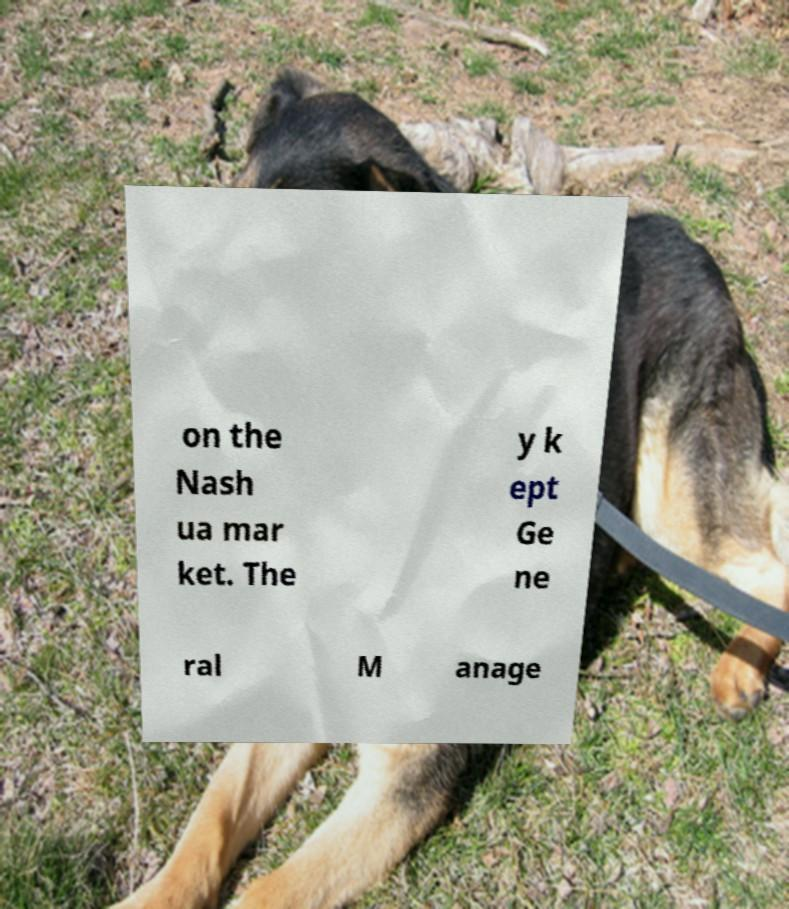There's text embedded in this image that I need extracted. Can you transcribe it verbatim? on the Nash ua mar ket. The y k ept Ge ne ral M anage 